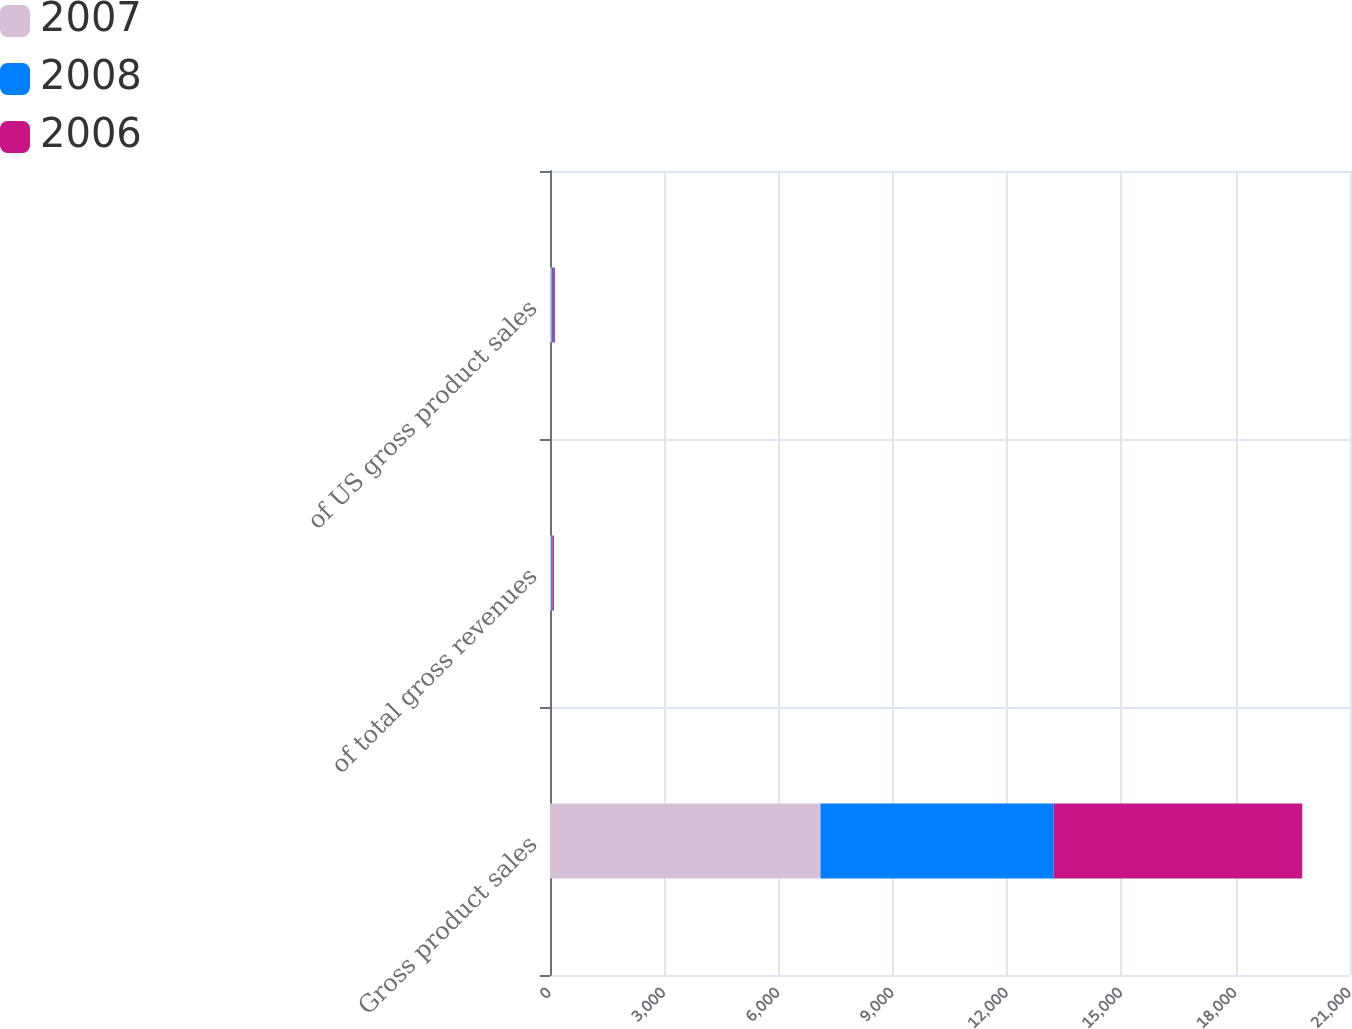Convert chart. <chart><loc_0><loc_0><loc_500><loc_500><stacked_bar_chart><ecel><fcel>Gross product sales<fcel>of total gross revenues<fcel>of US gross product sales<nl><fcel>2007<fcel>7099<fcel>37<fcel>46<nl><fcel>2008<fcel>6124<fcel>31<fcel>39<nl><fcel>2006<fcel>6523<fcel>35<fcel>42<nl></chart> 